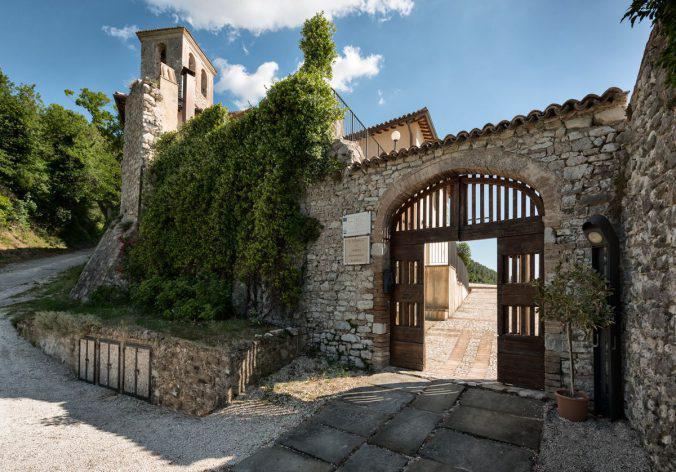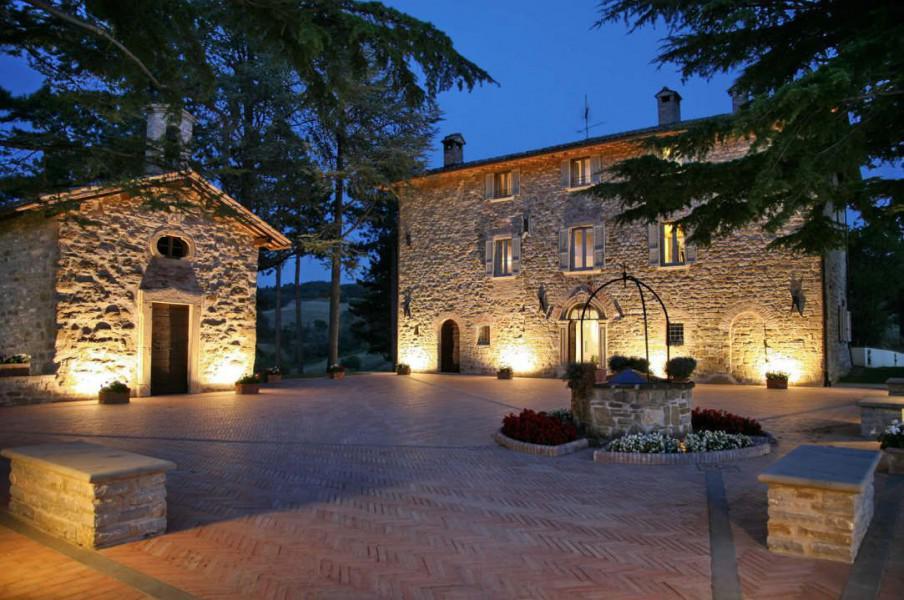The first image is the image on the left, the second image is the image on the right. Examine the images to the left and right. Is the description "There is a gazebo in one of the images." accurate? Answer yes or no. No. 